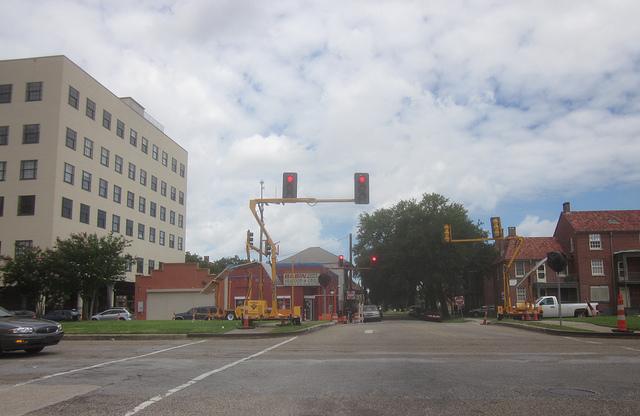How many traffic cones are pictured?
Write a very short answer. 0. Does your vehicle have to stop?
Keep it brief. Yes. Is there a bus?
Give a very brief answer. No. Are people in the street?
Keep it brief. No. Does the building on the left have a lot of windows?
Keep it brief. Yes. Is this a modern day picture?
Give a very brief answer. Yes. Is this photo in color?
Be succinct. Yes. Are there more cars than bicycles visible in this picture?
Give a very brief answer. Yes. How many stories is the tallest building in the photo?
Concise answer only. 6. Is this a small neighborhood?
Answer briefly. No. Is a highway being expanded or repaired?
Write a very short answer. No. How many red traffic lights are visible in this picture?
Write a very short answer. 4. How many red lights are showing?
Give a very brief answer. 4. How many vehicles are there?
Write a very short answer. 7. What shape are the two buildings?
Quick response, please. Square. Is this a modern picture?
Keep it brief. Yes. 